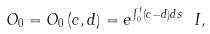<formula> <loc_0><loc_0><loc_500><loc_500>O _ { 0 } = O _ { 0 } \left ( c , d \right ) = e ^ { \int _ { 0 } ^ { t } \left ( c - d \right ) d s } \ I ,</formula> 